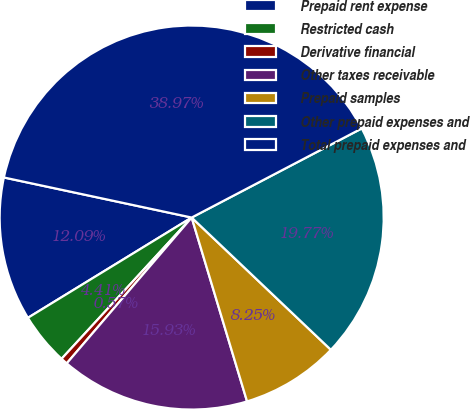<chart> <loc_0><loc_0><loc_500><loc_500><pie_chart><fcel>Prepaid rent expense<fcel>Restricted cash<fcel>Derivative financial<fcel>Other taxes receivable<fcel>Prepaid samples<fcel>Other prepaid expenses and<fcel>Total prepaid expenses and<nl><fcel>12.09%<fcel>4.41%<fcel>0.57%<fcel>15.93%<fcel>8.25%<fcel>19.77%<fcel>38.97%<nl></chart> 